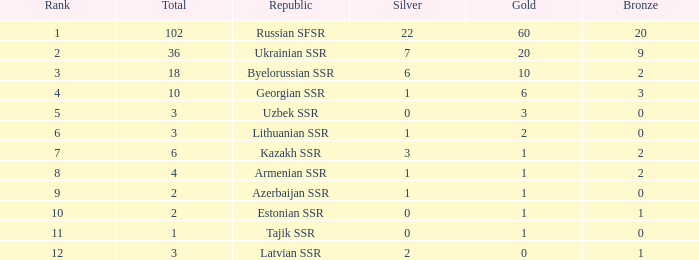What is the average total for teams with more than 1 gold, ranked over 3 and more than 3 bronze? None. 